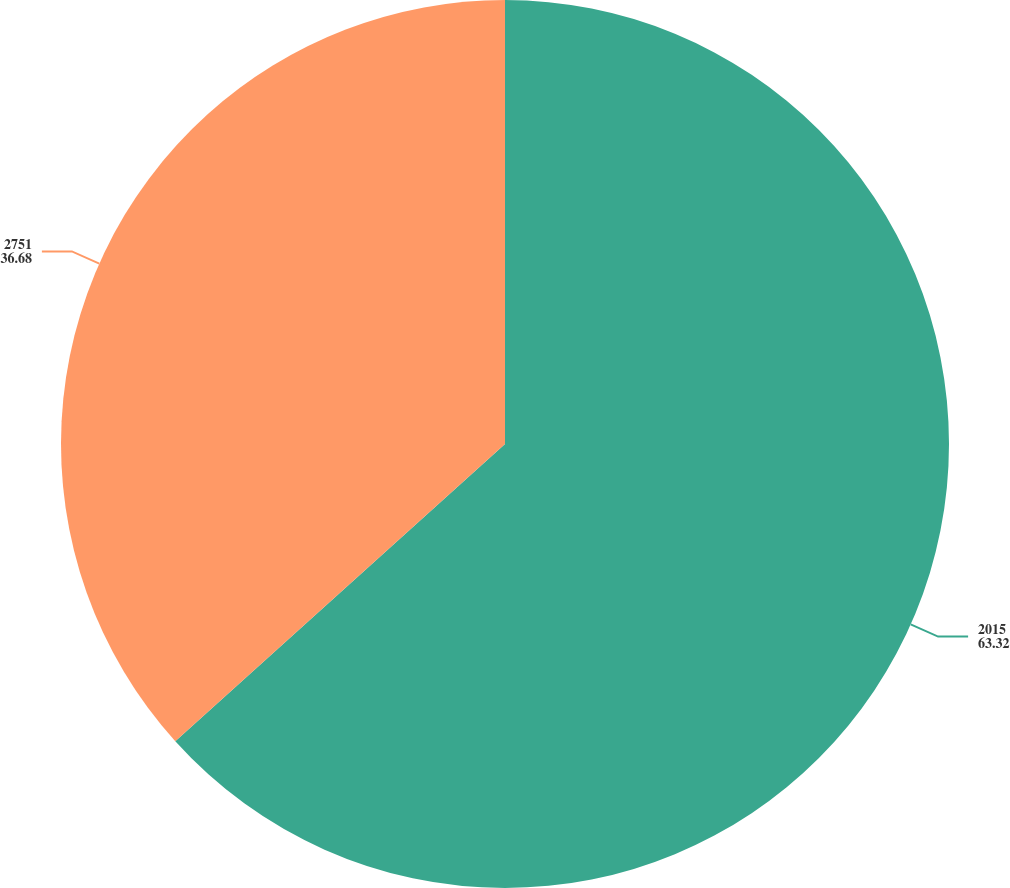<chart> <loc_0><loc_0><loc_500><loc_500><pie_chart><fcel>2015<fcel>2751<nl><fcel>63.32%<fcel>36.68%<nl></chart> 